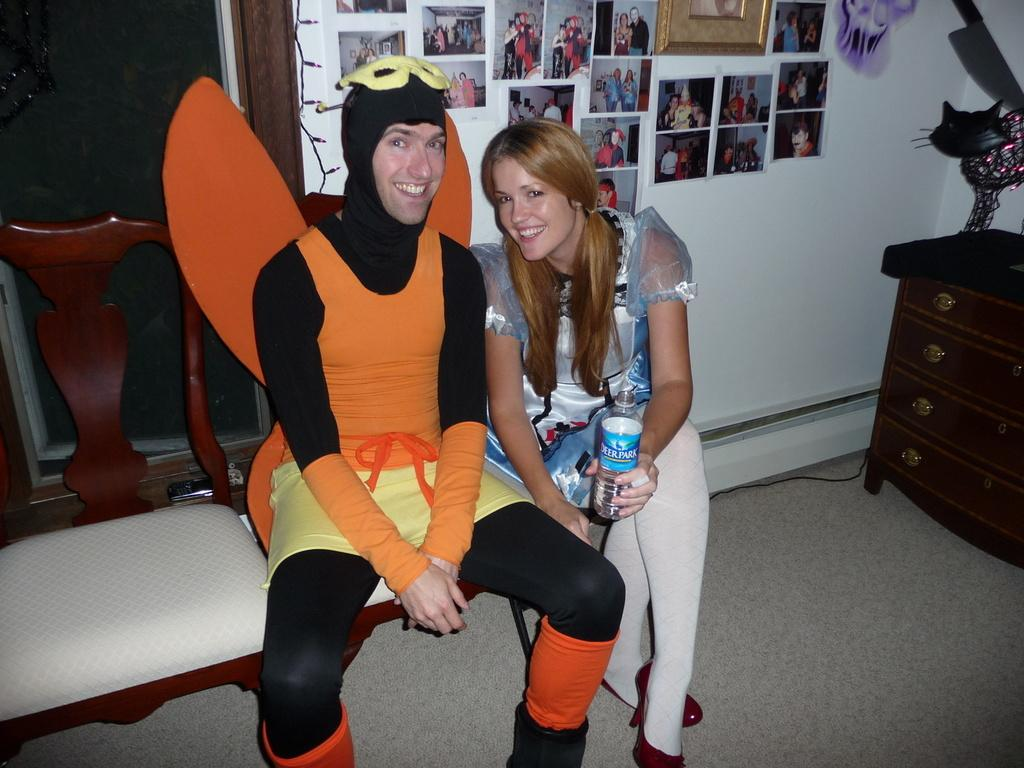How many people are in the image? There are two persons in the image. What are the positions of the persons in the image? Both persons are sitting on chairs. Can you describe the attire of one of the persons? One person is a man wearing a fancy dress. What is the woman holding in the image? The woman is holding a bottle. What can be seen on the wall in the image? There are different types of pictures on the wall. What type of furniture is present in the image? There is a cupboard in the image. What is the reason the sister is not present in the image? There is no mention of a sister in the image or the provided facts, so it is not possible to determine the reason for her absence. 